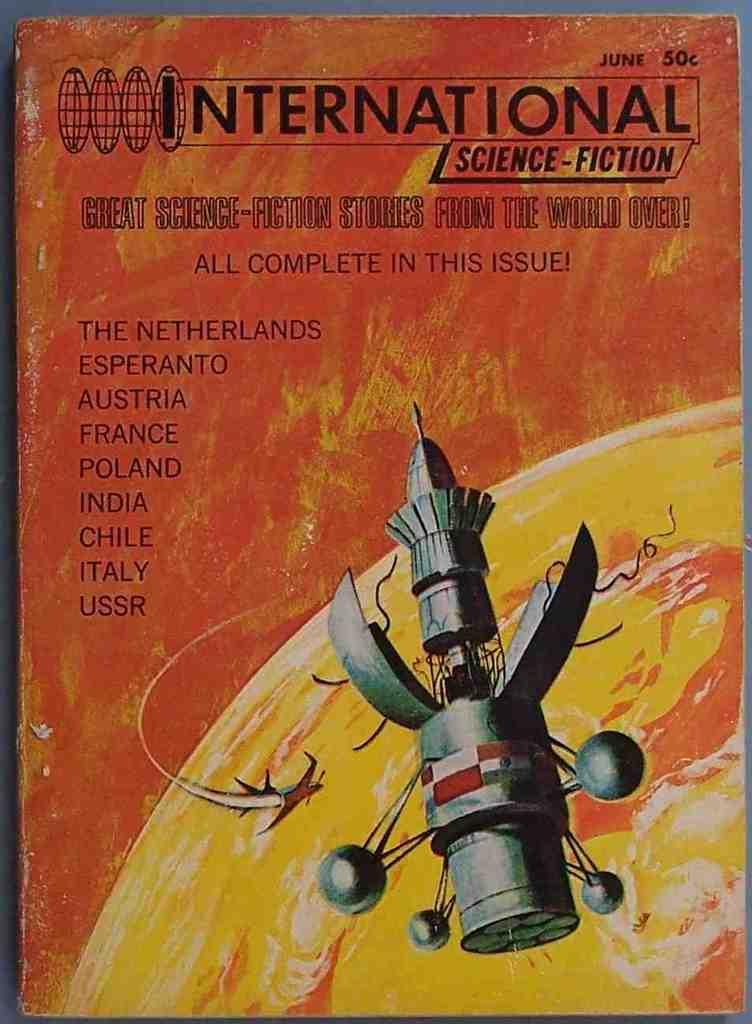<image>
Relay a brief, clear account of the picture shown. A sign that says International Science-Fiction on the title 